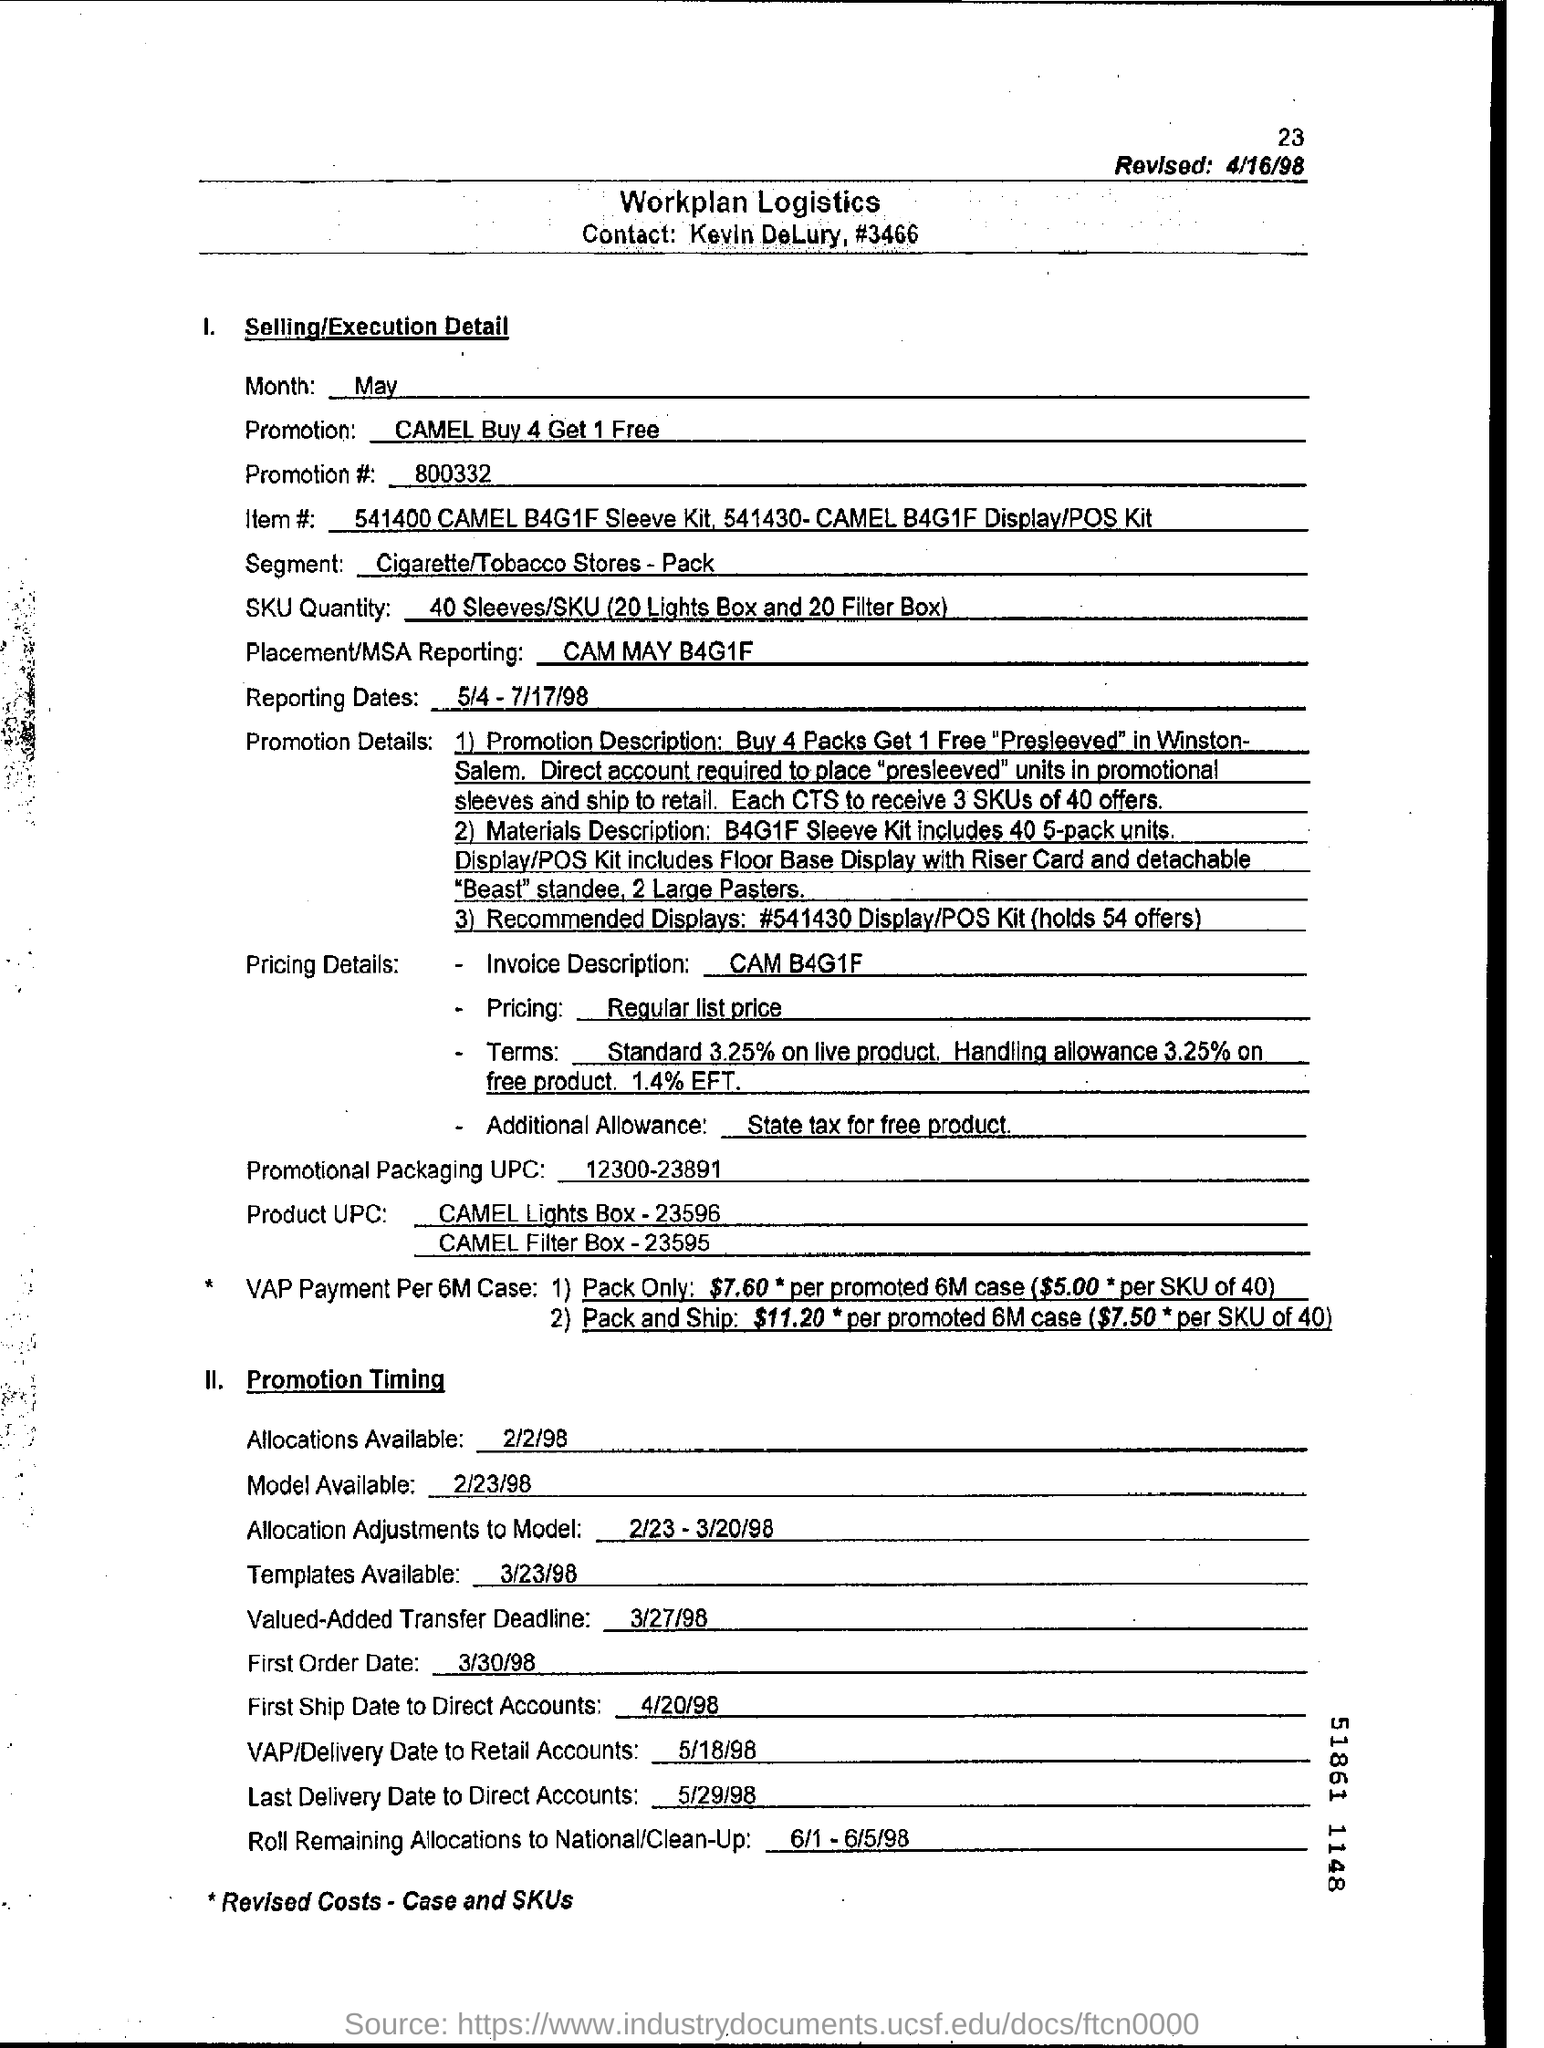What is the Promotion?
Make the answer very short. CAMEL Buy 4 Get 1 Free. What is the Promotion #?
Your answer should be compact. 800332. What is the Segment?
Your response must be concise. Cigarette/Tobacco Stores - Pack. What are the Reporting Dates?
Your response must be concise. 5/4 - 7/17/98. What is the First Order Date?
Offer a very short reply. 3/30/98. What is the Value-Added Transfer Deadline?
Make the answer very short. 3/27/98. 